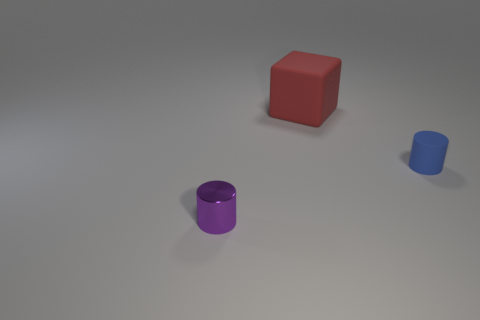Is there any other thing that is made of the same material as the small purple cylinder?
Your answer should be compact. No. Is there anything else that is the same size as the red thing?
Make the answer very short. No. How many other objects are there of the same size as the purple shiny cylinder?
Make the answer very short. 1. What is the color of the small cylinder that is behind the small object that is on the left side of the tiny object on the right side of the red block?
Offer a very short reply. Blue. What number of other objects are the same shape as the tiny matte object?
Your answer should be compact. 1. What shape is the object in front of the tiny blue rubber thing?
Your answer should be compact. Cylinder. There is a thing that is to the right of the big red matte thing; is there a purple cylinder that is in front of it?
Ensure brevity in your answer.  Yes. There is a object that is both to the left of the blue rubber cylinder and in front of the large red rubber block; what color is it?
Ensure brevity in your answer.  Purple. There is a small thing on the left side of the tiny cylinder that is to the right of the purple object; is there a blue rubber cylinder behind it?
Offer a terse response. Yes. Are any things visible?
Keep it short and to the point. Yes. 